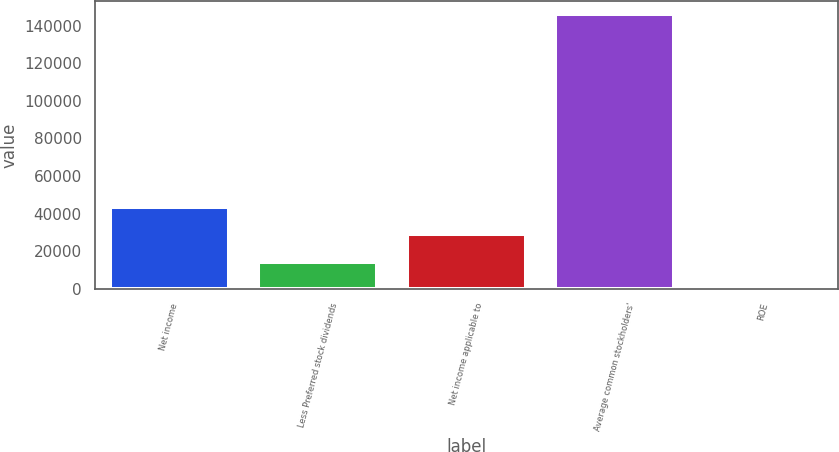Convert chart. <chart><loc_0><loc_0><loc_500><loc_500><bar_chart><fcel>Net income<fcel>Less Preferred stock dividends<fcel>Net income applicable to<fcel>Average common stockholders'<fcel>ROE<nl><fcel>43775.1<fcel>14595.7<fcel>29185.4<fcel>145903<fcel>6<nl></chart> 